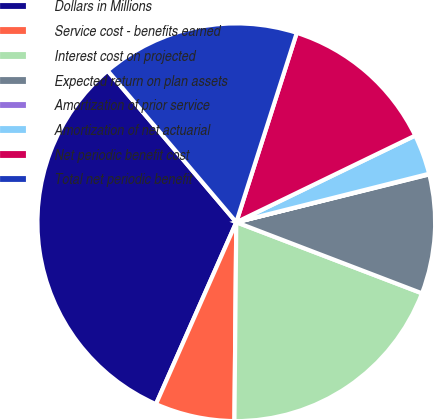Convert chart to OTSL. <chart><loc_0><loc_0><loc_500><loc_500><pie_chart><fcel>Dollars in Millions<fcel>Service cost - benefits earned<fcel>Interest cost on projected<fcel>Expected return on plan assets<fcel>Amortization of prior service<fcel>Amortization of net actuarial<fcel>Net periodic benefit cost<fcel>Total net periodic benefit<nl><fcel>32.18%<fcel>6.47%<fcel>19.33%<fcel>9.69%<fcel>0.05%<fcel>3.26%<fcel>12.9%<fcel>16.12%<nl></chart> 